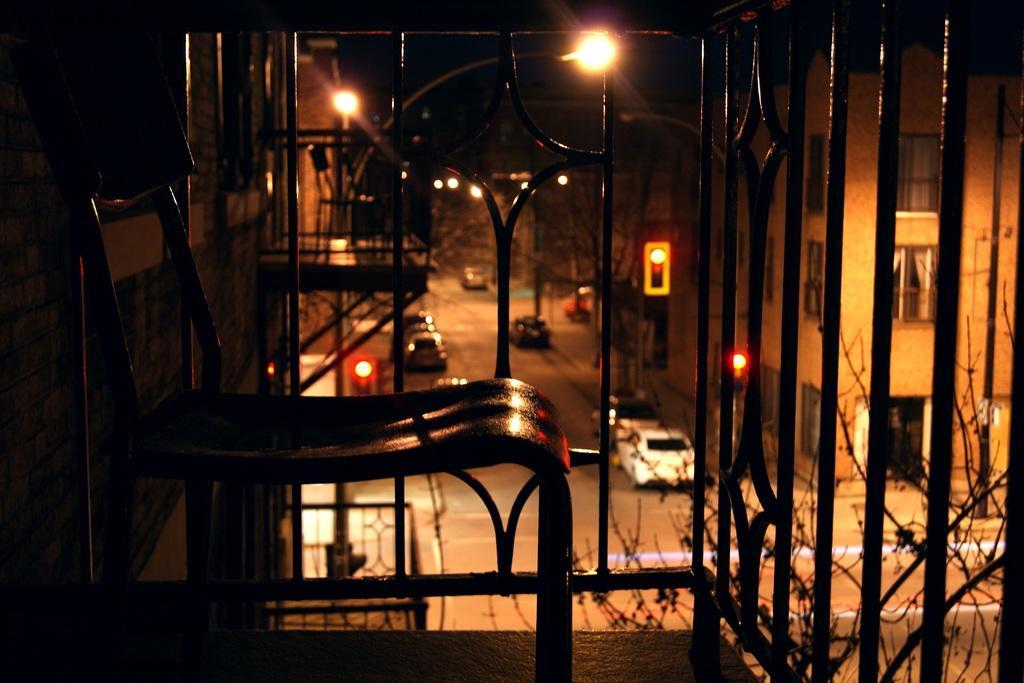Please provide a concise description of this image. This is an image clicked in the dark. In the foreground, I can see the railing and a chair. In the background there are some buildings, some cars on the road and I can see the street lights. 